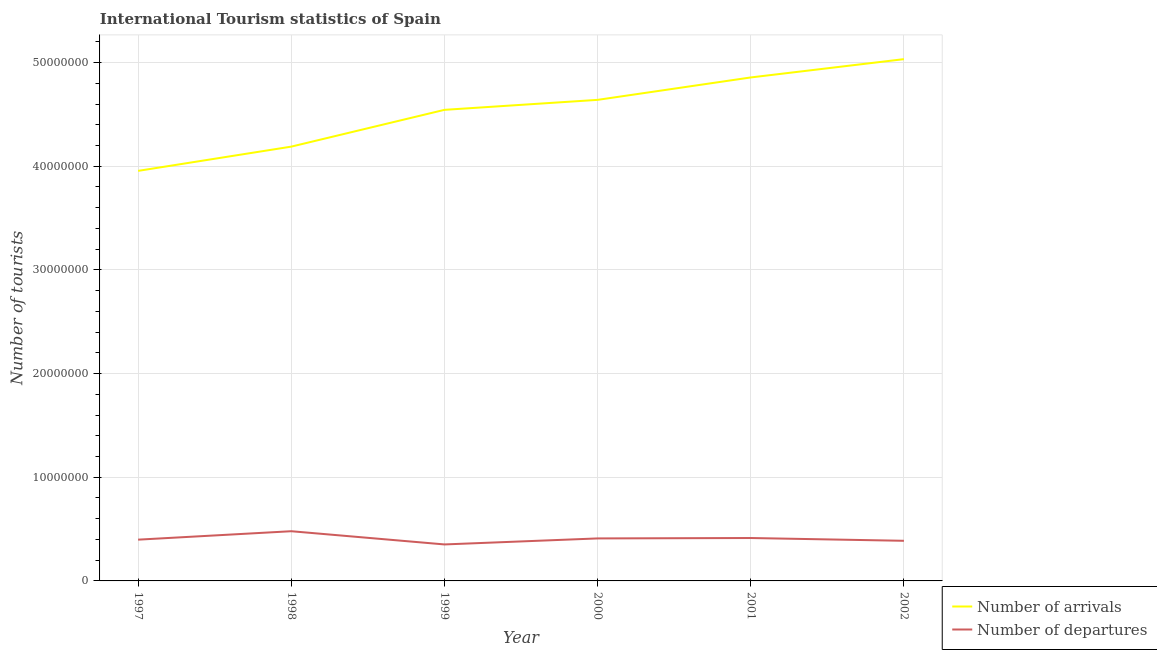Does the line corresponding to number of tourist departures intersect with the line corresponding to number of tourist arrivals?
Provide a short and direct response. No. Is the number of lines equal to the number of legend labels?
Your response must be concise. Yes. What is the number of tourist arrivals in 1997?
Keep it short and to the point. 3.96e+07. Across all years, what is the maximum number of tourist arrivals?
Offer a terse response. 5.03e+07. Across all years, what is the minimum number of tourist departures?
Your response must be concise. 3.52e+06. In which year was the number of tourist departures minimum?
Keep it short and to the point. 1999. What is the total number of tourist arrivals in the graph?
Provide a succinct answer. 2.72e+08. What is the difference between the number of tourist departures in 1998 and that in 1999?
Your answer should be very brief. 1.28e+06. What is the difference between the number of tourist arrivals in 1997 and the number of tourist departures in 2001?
Ensure brevity in your answer.  3.54e+07. What is the average number of tourist departures per year?
Your answer should be very brief. 4.07e+06. In the year 2002, what is the difference between the number of tourist arrivals and number of tourist departures?
Your response must be concise. 4.65e+07. In how many years, is the number of tourist departures greater than 22000000?
Your answer should be compact. 0. What is the ratio of the number of tourist departures in 1998 to that in 2001?
Give a very brief answer. 1.16. What is the difference between the highest and the second highest number of tourist departures?
Keep it short and to the point. 6.55e+05. What is the difference between the highest and the lowest number of tourist departures?
Provide a succinct answer. 1.28e+06. In how many years, is the number of tourist arrivals greater than the average number of tourist arrivals taken over all years?
Your answer should be compact. 4. Is the sum of the number of tourist arrivals in 1997 and 1998 greater than the maximum number of tourist departures across all years?
Keep it short and to the point. Yes. Does the number of tourist departures monotonically increase over the years?
Keep it short and to the point. No. Is the number of tourist arrivals strictly greater than the number of tourist departures over the years?
Offer a very short reply. Yes. How many years are there in the graph?
Offer a terse response. 6. What is the difference between two consecutive major ticks on the Y-axis?
Make the answer very short. 1.00e+07. Are the values on the major ticks of Y-axis written in scientific E-notation?
Provide a succinct answer. No. Does the graph contain any zero values?
Your answer should be compact. No. Does the graph contain grids?
Your answer should be very brief. Yes. How are the legend labels stacked?
Your response must be concise. Vertical. What is the title of the graph?
Your response must be concise. International Tourism statistics of Spain. What is the label or title of the X-axis?
Your answer should be compact. Year. What is the label or title of the Y-axis?
Provide a short and direct response. Number of tourists. What is the Number of tourists of Number of arrivals in 1997?
Provide a succinct answer. 3.96e+07. What is the Number of tourists in Number of departures in 1997?
Make the answer very short. 3.98e+06. What is the Number of tourists of Number of arrivals in 1998?
Your answer should be compact. 4.19e+07. What is the Number of tourists in Number of departures in 1998?
Make the answer very short. 4.79e+06. What is the Number of tourists in Number of arrivals in 1999?
Offer a very short reply. 4.54e+07. What is the Number of tourists of Number of departures in 1999?
Your response must be concise. 3.52e+06. What is the Number of tourists in Number of arrivals in 2000?
Keep it short and to the point. 4.64e+07. What is the Number of tourists in Number of departures in 2000?
Ensure brevity in your answer.  4.10e+06. What is the Number of tourists in Number of arrivals in 2001?
Your answer should be compact. 4.86e+07. What is the Number of tourists in Number of departures in 2001?
Ensure brevity in your answer.  4.14e+06. What is the Number of tourists in Number of arrivals in 2002?
Offer a terse response. 5.03e+07. What is the Number of tourists in Number of departures in 2002?
Your response must be concise. 3.87e+06. Across all years, what is the maximum Number of tourists of Number of arrivals?
Your answer should be compact. 5.03e+07. Across all years, what is the maximum Number of tourists in Number of departures?
Your response must be concise. 4.79e+06. Across all years, what is the minimum Number of tourists of Number of arrivals?
Make the answer very short. 3.96e+07. Across all years, what is the minimum Number of tourists of Number of departures?
Provide a succinct answer. 3.52e+06. What is the total Number of tourists of Number of arrivals in the graph?
Keep it short and to the point. 2.72e+08. What is the total Number of tourists of Number of departures in the graph?
Your answer should be compact. 2.44e+07. What is the difference between the Number of tourists of Number of arrivals in 1997 and that in 1998?
Your response must be concise. -2.34e+06. What is the difference between the Number of tourists in Number of departures in 1997 and that in 1998?
Provide a short and direct response. -8.14e+05. What is the difference between the Number of tourists in Number of arrivals in 1997 and that in 1999?
Provide a short and direct response. -5.89e+06. What is the difference between the Number of tourists of Number of departures in 1997 and that in 1999?
Your answer should be very brief. 4.61e+05. What is the difference between the Number of tourists in Number of arrivals in 1997 and that in 2000?
Your answer should be compact. -6.85e+06. What is the difference between the Number of tourists of Number of arrivals in 1997 and that in 2001?
Give a very brief answer. -9.01e+06. What is the difference between the Number of tourists in Number of departures in 1997 and that in 2001?
Make the answer very short. -1.59e+05. What is the difference between the Number of tourists in Number of arrivals in 1997 and that in 2002?
Provide a succinct answer. -1.08e+07. What is the difference between the Number of tourists in Number of departures in 1997 and that in 2002?
Offer a terse response. 1.09e+05. What is the difference between the Number of tourists of Number of arrivals in 1998 and that in 1999?
Your answer should be compact. -3.55e+06. What is the difference between the Number of tourists of Number of departures in 1998 and that in 1999?
Ensure brevity in your answer.  1.28e+06. What is the difference between the Number of tourists of Number of arrivals in 1998 and that in 2000?
Keep it short and to the point. -4.51e+06. What is the difference between the Number of tourists in Number of departures in 1998 and that in 2000?
Give a very brief answer. 6.94e+05. What is the difference between the Number of tourists of Number of arrivals in 1998 and that in 2001?
Make the answer very short. -6.67e+06. What is the difference between the Number of tourists in Number of departures in 1998 and that in 2001?
Your answer should be very brief. 6.55e+05. What is the difference between the Number of tourists in Number of arrivals in 1998 and that in 2002?
Provide a short and direct response. -8.44e+06. What is the difference between the Number of tourists in Number of departures in 1998 and that in 2002?
Make the answer very short. 9.23e+05. What is the difference between the Number of tourists of Number of arrivals in 1999 and that in 2000?
Ensure brevity in your answer.  -9.63e+05. What is the difference between the Number of tourists of Number of departures in 1999 and that in 2000?
Your answer should be compact. -5.81e+05. What is the difference between the Number of tourists of Number of arrivals in 1999 and that in 2001?
Ensure brevity in your answer.  -3.12e+06. What is the difference between the Number of tourists of Number of departures in 1999 and that in 2001?
Make the answer very short. -6.20e+05. What is the difference between the Number of tourists of Number of arrivals in 1999 and that in 2002?
Keep it short and to the point. -4.89e+06. What is the difference between the Number of tourists of Number of departures in 1999 and that in 2002?
Make the answer very short. -3.52e+05. What is the difference between the Number of tourists in Number of arrivals in 2000 and that in 2001?
Give a very brief answer. -2.16e+06. What is the difference between the Number of tourists of Number of departures in 2000 and that in 2001?
Keep it short and to the point. -3.90e+04. What is the difference between the Number of tourists in Number of arrivals in 2000 and that in 2002?
Provide a succinct answer. -3.93e+06. What is the difference between the Number of tourists of Number of departures in 2000 and that in 2002?
Provide a succinct answer. 2.29e+05. What is the difference between the Number of tourists of Number of arrivals in 2001 and that in 2002?
Make the answer very short. -1.77e+06. What is the difference between the Number of tourists of Number of departures in 2001 and that in 2002?
Provide a short and direct response. 2.68e+05. What is the difference between the Number of tourists in Number of arrivals in 1997 and the Number of tourists in Number of departures in 1998?
Your answer should be compact. 3.48e+07. What is the difference between the Number of tourists of Number of arrivals in 1997 and the Number of tourists of Number of departures in 1999?
Your response must be concise. 3.60e+07. What is the difference between the Number of tourists of Number of arrivals in 1997 and the Number of tourists of Number of departures in 2000?
Ensure brevity in your answer.  3.55e+07. What is the difference between the Number of tourists of Number of arrivals in 1997 and the Number of tourists of Number of departures in 2001?
Give a very brief answer. 3.54e+07. What is the difference between the Number of tourists in Number of arrivals in 1997 and the Number of tourists in Number of departures in 2002?
Provide a succinct answer. 3.57e+07. What is the difference between the Number of tourists in Number of arrivals in 1998 and the Number of tourists in Number of departures in 1999?
Ensure brevity in your answer.  3.84e+07. What is the difference between the Number of tourists of Number of arrivals in 1998 and the Number of tourists of Number of departures in 2000?
Offer a very short reply. 3.78e+07. What is the difference between the Number of tourists in Number of arrivals in 1998 and the Number of tourists in Number of departures in 2001?
Offer a terse response. 3.78e+07. What is the difference between the Number of tourists of Number of arrivals in 1998 and the Number of tourists of Number of departures in 2002?
Offer a very short reply. 3.80e+07. What is the difference between the Number of tourists of Number of arrivals in 1999 and the Number of tourists of Number of departures in 2000?
Offer a terse response. 4.13e+07. What is the difference between the Number of tourists of Number of arrivals in 1999 and the Number of tourists of Number of departures in 2001?
Your answer should be very brief. 4.13e+07. What is the difference between the Number of tourists in Number of arrivals in 1999 and the Number of tourists in Number of departures in 2002?
Your answer should be compact. 4.16e+07. What is the difference between the Number of tourists in Number of arrivals in 2000 and the Number of tourists in Number of departures in 2001?
Ensure brevity in your answer.  4.23e+07. What is the difference between the Number of tourists of Number of arrivals in 2000 and the Number of tourists of Number of departures in 2002?
Provide a short and direct response. 4.25e+07. What is the difference between the Number of tourists of Number of arrivals in 2001 and the Number of tourists of Number of departures in 2002?
Make the answer very short. 4.47e+07. What is the average Number of tourists in Number of arrivals per year?
Your response must be concise. 4.54e+07. What is the average Number of tourists of Number of departures per year?
Your response must be concise. 4.07e+06. In the year 1997, what is the difference between the Number of tourists in Number of arrivals and Number of tourists in Number of departures?
Make the answer very short. 3.56e+07. In the year 1998, what is the difference between the Number of tourists in Number of arrivals and Number of tourists in Number of departures?
Ensure brevity in your answer.  3.71e+07. In the year 1999, what is the difference between the Number of tourists in Number of arrivals and Number of tourists in Number of departures?
Your answer should be compact. 4.19e+07. In the year 2000, what is the difference between the Number of tourists in Number of arrivals and Number of tourists in Number of departures?
Offer a terse response. 4.23e+07. In the year 2001, what is the difference between the Number of tourists of Number of arrivals and Number of tourists of Number of departures?
Your answer should be compact. 4.44e+07. In the year 2002, what is the difference between the Number of tourists in Number of arrivals and Number of tourists in Number of departures?
Make the answer very short. 4.65e+07. What is the ratio of the Number of tourists of Number of arrivals in 1997 to that in 1998?
Make the answer very short. 0.94. What is the ratio of the Number of tourists in Number of departures in 1997 to that in 1998?
Keep it short and to the point. 0.83. What is the ratio of the Number of tourists in Number of arrivals in 1997 to that in 1999?
Your answer should be compact. 0.87. What is the ratio of the Number of tourists of Number of departures in 1997 to that in 1999?
Provide a succinct answer. 1.13. What is the ratio of the Number of tourists of Number of arrivals in 1997 to that in 2000?
Give a very brief answer. 0.85. What is the ratio of the Number of tourists of Number of departures in 1997 to that in 2000?
Your response must be concise. 0.97. What is the ratio of the Number of tourists of Number of arrivals in 1997 to that in 2001?
Your answer should be compact. 0.81. What is the ratio of the Number of tourists of Number of departures in 1997 to that in 2001?
Give a very brief answer. 0.96. What is the ratio of the Number of tourists of Number of arrivals in 1997 to that in 2002?
Make the answer very short. 0.79. What is the ratio of the Number of tourists in Number of departures in 1997 to that in 2002?
Provide a succinct answer. 1.03. What is the ratio of the Number of tourists of Number of arrivals in 1998 to that in 1999?
Provide a short and direct response. 0.92. What is the ratio of the Number of tourists in Number of departures in 1998 to that in 1999?
Your response must be concise. 1.36. What is the ratio of the Number of tourists of Number of arrivals in 1998 to that in 2000?
Offer a very short reply. 0.9. What is the ratio of the Number of tourists in Number of departures in 1998 to that in 2000?
Offer a very short reply. 1.17. What is the ratio of the Number of tourists in Number of arrivals in 1998 to that in 2001?
Your answer should be very brief. 0.86. What is the ratio of the Number of tourists in Number of departures in 1998 to that in 2001?
Offer a very short reply. 1.16. What is the ratio of the Number of tourists of Number of arrivals in 1998 to that in 2002?
Provide a succinct answer. 0.83. What is the ratio of the Number of tourists in Number of departures in 1998 to that in 2002?
Offer a very short reply. 1.24. What is the ratio of the Number of tourists in Number of arrivals in 1999 to that in 2000?
Offer a very short reply. 0.98. What is the ratio of the Number of tourists in Number of departures in 1999 to that in 2000?
Your answer should be compact. 0.86. What is the ratio of the Number of tourists of Number of arrivals in 1999 to that in 2001?
Offer a very short reply. 0.94. What is the ratio of the Number of tourists of Number of departures in 1999 to that in 2001?
Provide a short and direct response. 0.85. What is the ratio of the Number of tourists in Number of arrivals in 1999 to that in 2002?
Provide a short and direct response. 0.9. What is the ratio of the Number of tourists of Number of arrivals in 2000 to that in 2001?
Keep it short and to the point. 0.96. What is the ratio of the Number of tourists of Number of departures in 2000 to that in 2001?
Ensure brevity in your answer.  0.99. What is the ratio of the Number of tourists in Number of arrivals in 2000 to that in 2002?
Your response must be concise. 0.92. What is the ratio of the Number of tourists in Number of departures in 2000 to that in 2002?
Make the answer very short. 1.06. What is the ratio of the Number of tourists of Number of arrivals in 2001 to that in 2002?
Offer a very short reply. 0.96. What is the ratio of the Number of tourists in Number of departures in 2001 to that in 2002?
Your answer should be very brief. 1.07. What is the difference between the highest and the second highest Number of tourists of Number of arrivals?
Your answer should be very brief. 1.77e+06. What is the difference between the highest and the second highest Number of tourists of Number of departures?
Keep it short and to the point. 6.55e+05. What is the difference between the highest and the lowest Number of tourists in Number of arrivals?
Offer a very short reply. 1.08e+07. What is the difference between the highest and the lowest Number of tourists in Number of departures?
Keep it short and to the point. 1.28e+06. 